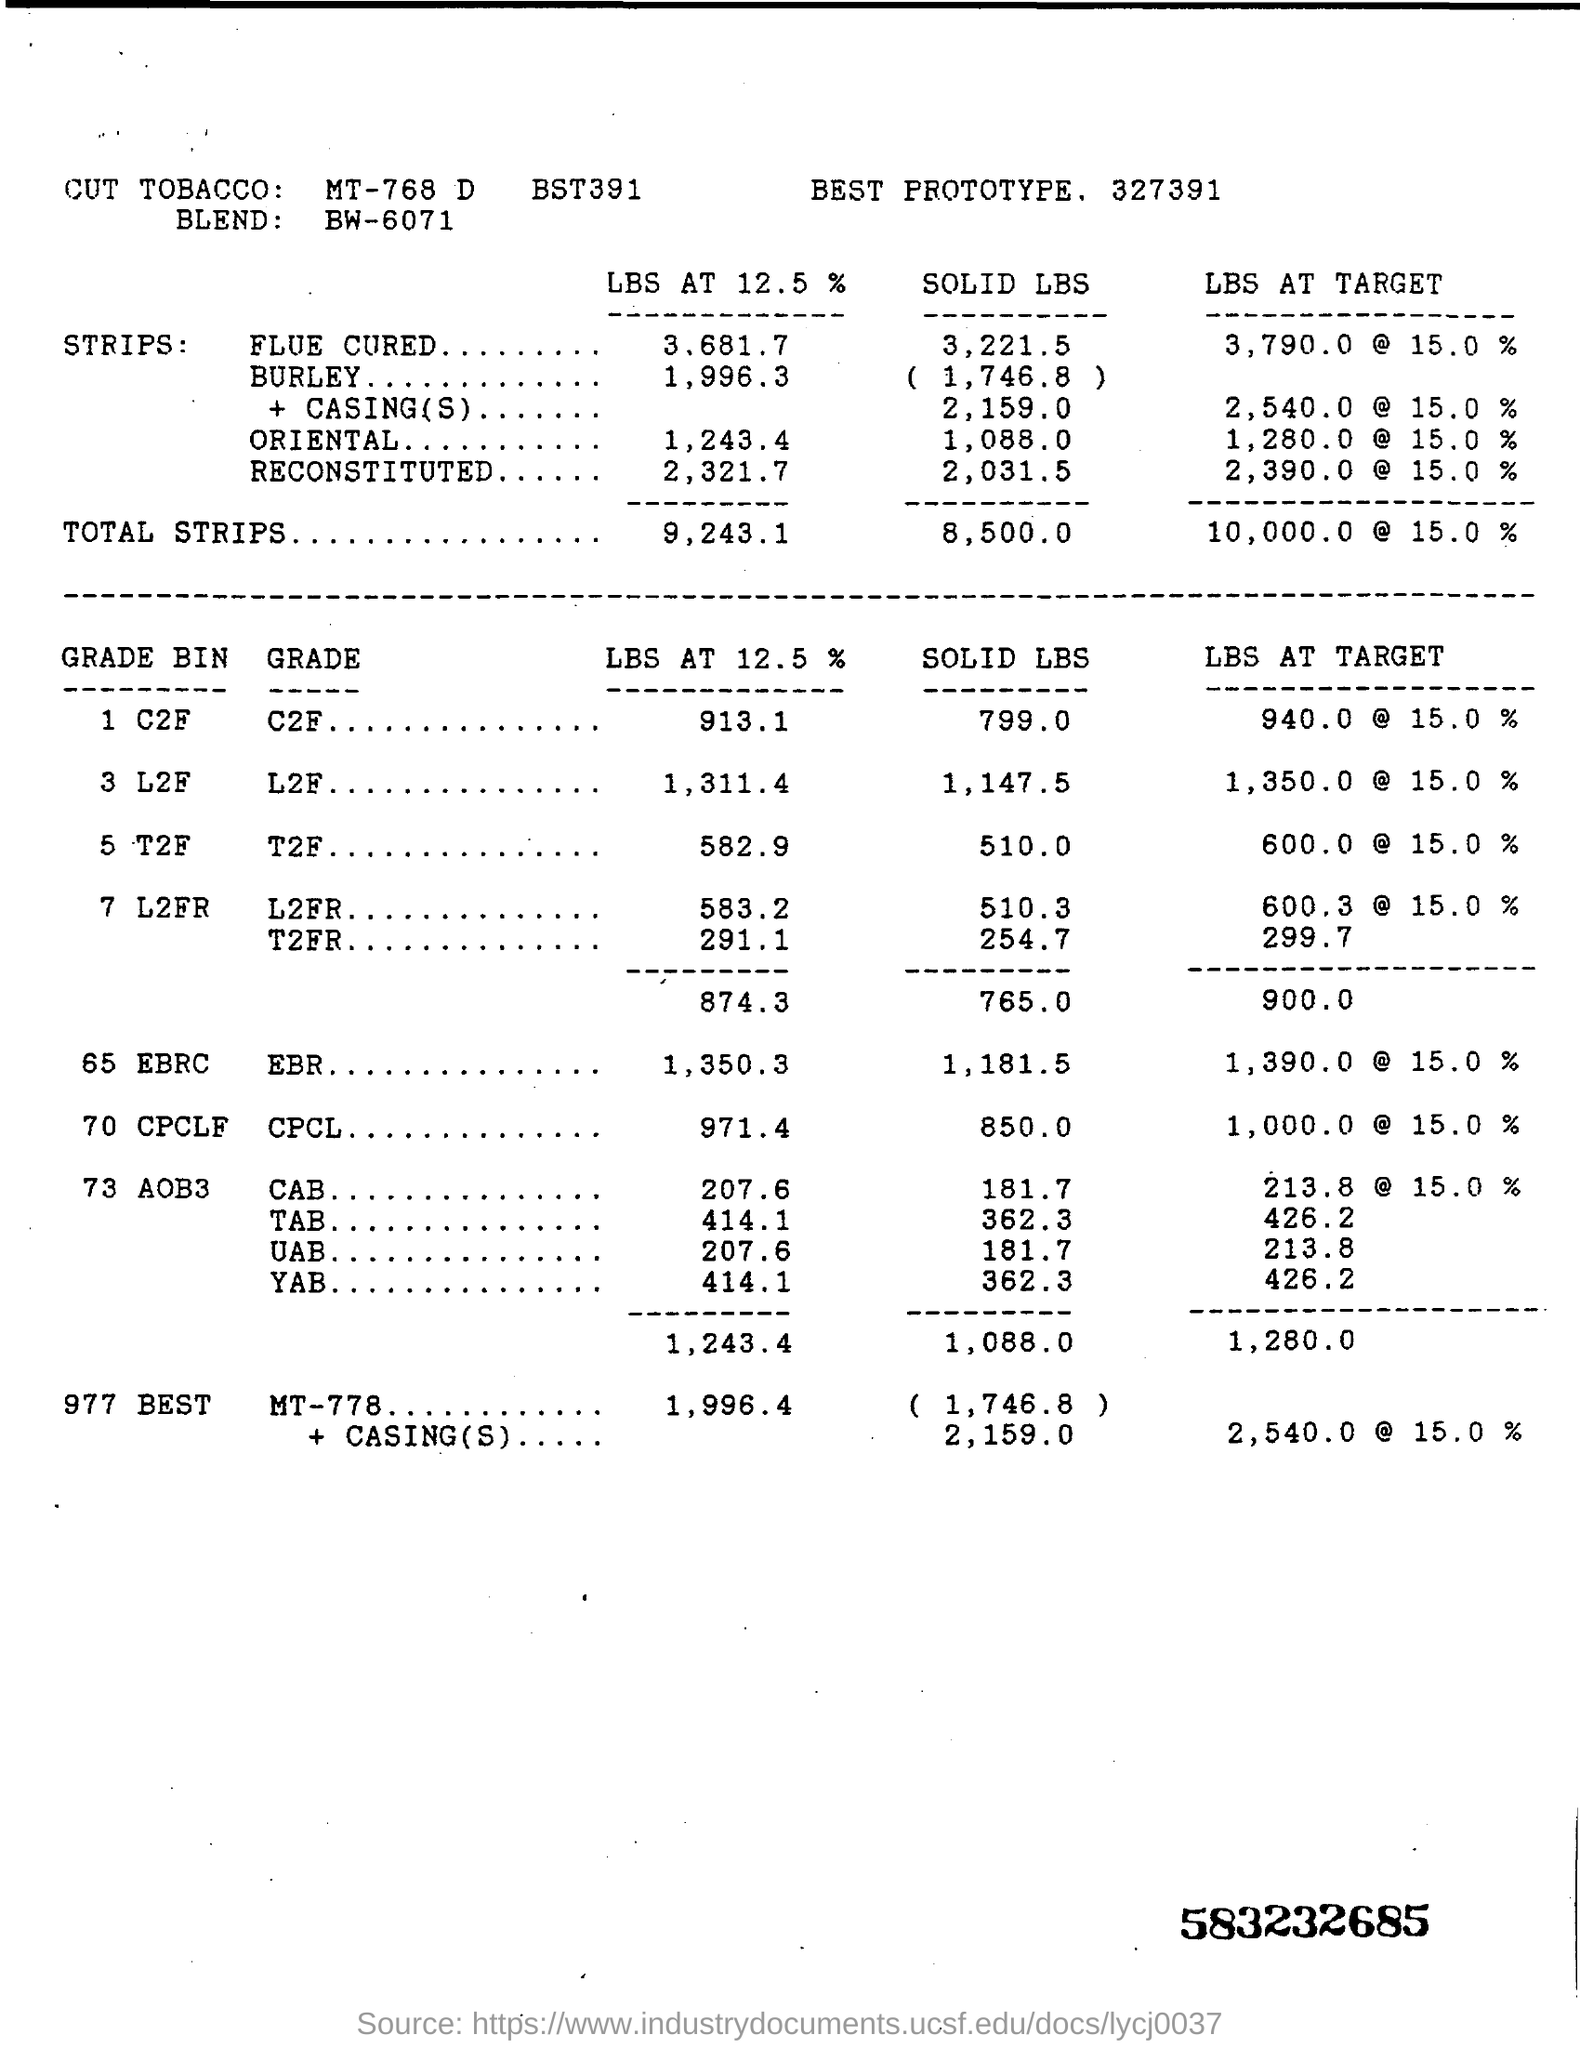Outline some significant characteristics in this image. The term 'BLEND' refers to the BW-6071... What is the SOLID LBS of T2F GRADE? 510.." is a question that asks for information about the SOLID LBS of T2F GRADE. 